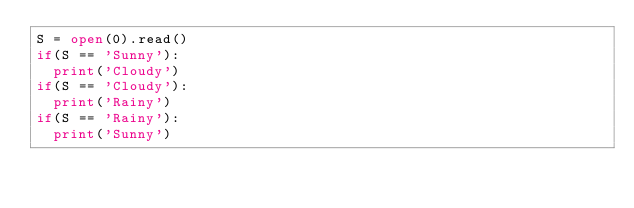Convert code to text. <code><loc_0><loc_0><loc_500><loc_500><_Python_>S = open(0).read()
if(S == 'Sunny'):
  print('Cloudy')
if(S == 'Cloudy'):
  print('Rainy')
if(S == 'Rainy'):
  print('Sunny')

</code> 